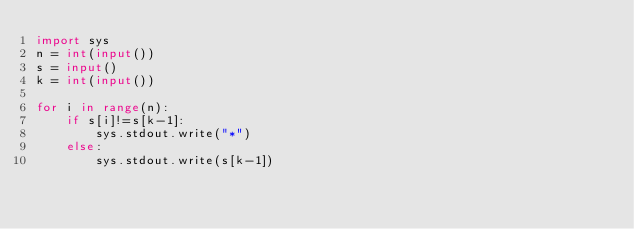Convert code to text. <code><loc_0><loc_0><loc_500><loc_500><_Python_>import sys
n = int(input())
s = input()
k = int(input())

for i in range(n):
    if s[i]!=s[k-1]:
        sys.stdout.write("*")
    else:
        sys.stdout.write(s[k-1])
</code> 